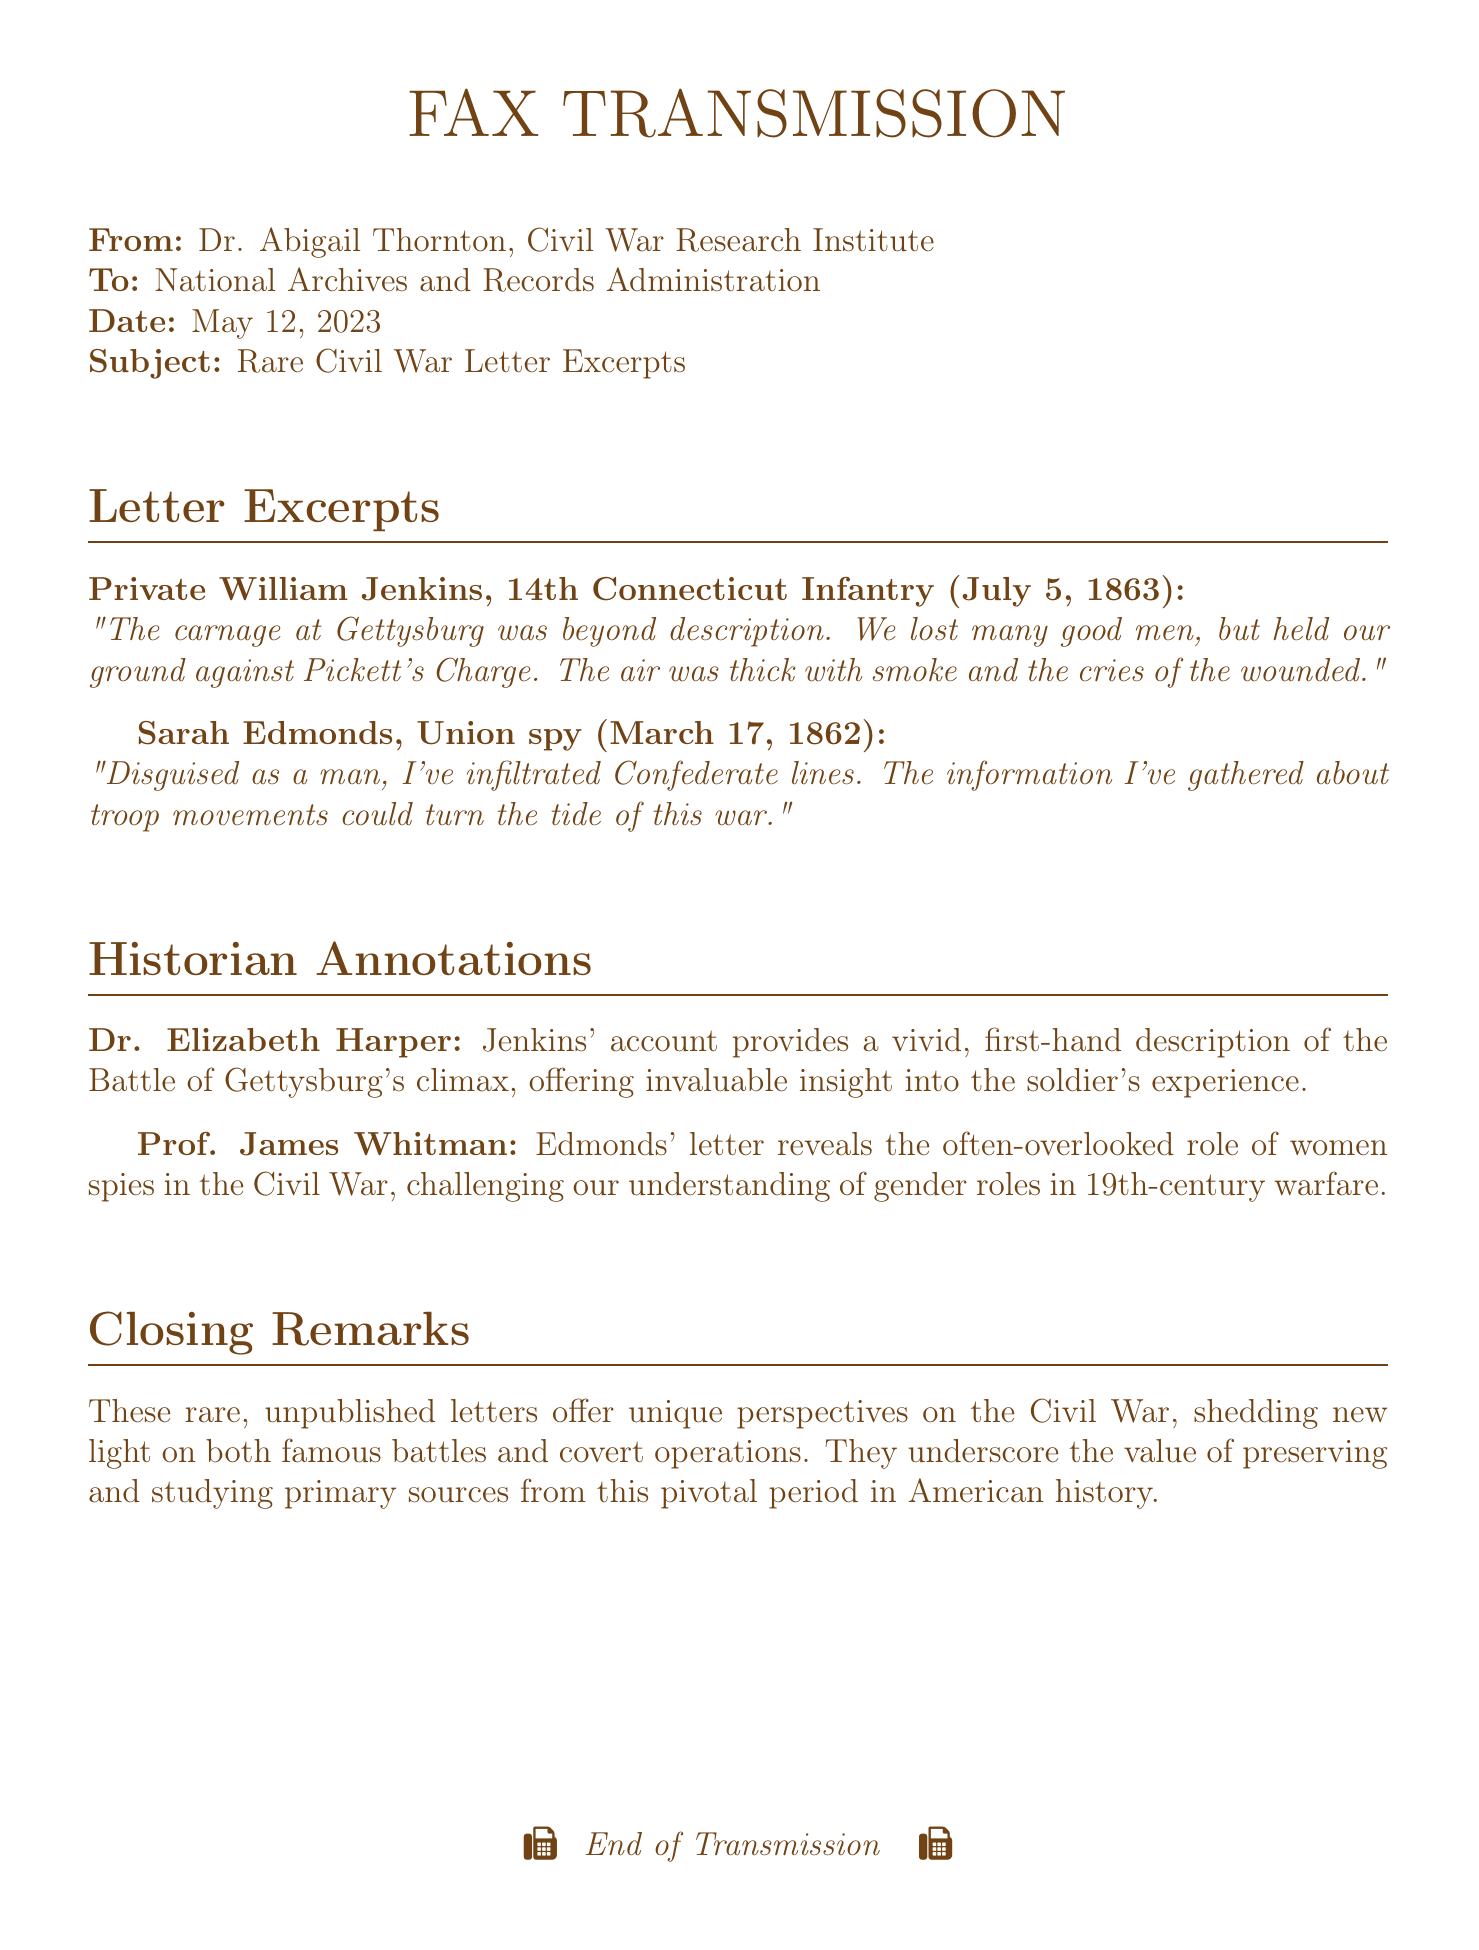What is the name of the historian who annotated Jenkins' letter? The document explicitly names Dr. Elizabeth Harper as the historian annotating Jenkins' letter.
Answer: Dr. Elizabeth Harper What was the date of Sarah Edmonds' letter? The document provides the date of Sarah Edmonds' letter as March 17, 1862.
Answer: March 17, 1862 Which battle does Private William Jenkins refer to in his letter? The excerpt from Jenkins' letter mentions the Battle of Gettysburg specifically.
Answer: Gettysburg What unique role does Sarah Edmonds occupy during the Civil War? The document identifies Sarah Edmonds as a Union spy, which indicates her unique role.
Answer: Union spy Who mentions the role of women spies in the Civil War? The annotations in the document credit Prof. James Whitman with the statement about women spies.
Answer: Prof. James Whitman What military unit did Private William Jenkins serve in? The document states that Private William Jenkins served in the 14th Connecticut Infantry.
Answer: 14th Connecticut Infantry What type of document is this fax categorized as? The document is a transmission of rare Civil War letters, specifying it as excerpts from unpublished letters.
Answer: Fax How many excerpts from letters are included in the document? The document includes two excerpts: one from Private Jenkins and another from Sarah Edmonds.
Answer: Two What is the overarching theme of the closing remarks? The closing remarks emphasize the importance of preserving and studying primary sources from the Civil War era.
Answer: Preserving and studying primary sources 